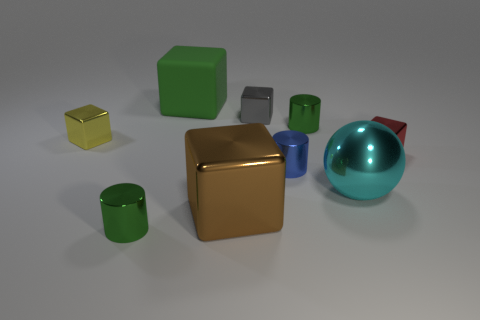There is a small gray object; are there any blue metal cylinders left of it? no 